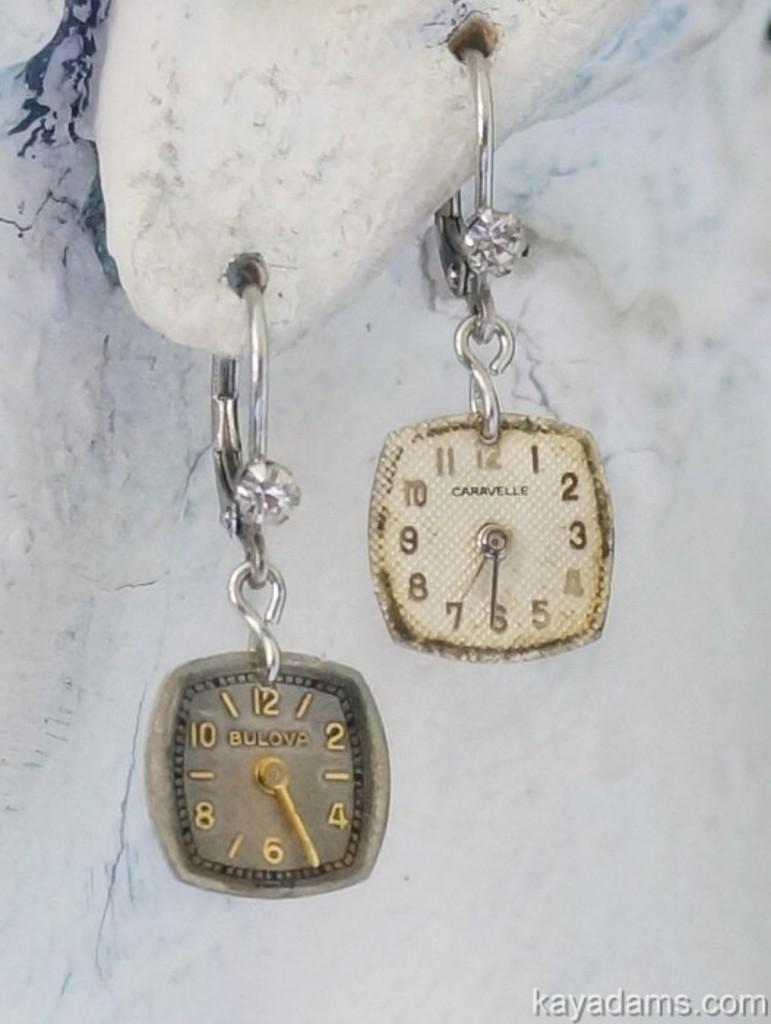How would you summarize this image in a sentence or two? As we can see in the image there is a white color wall and keychains. 